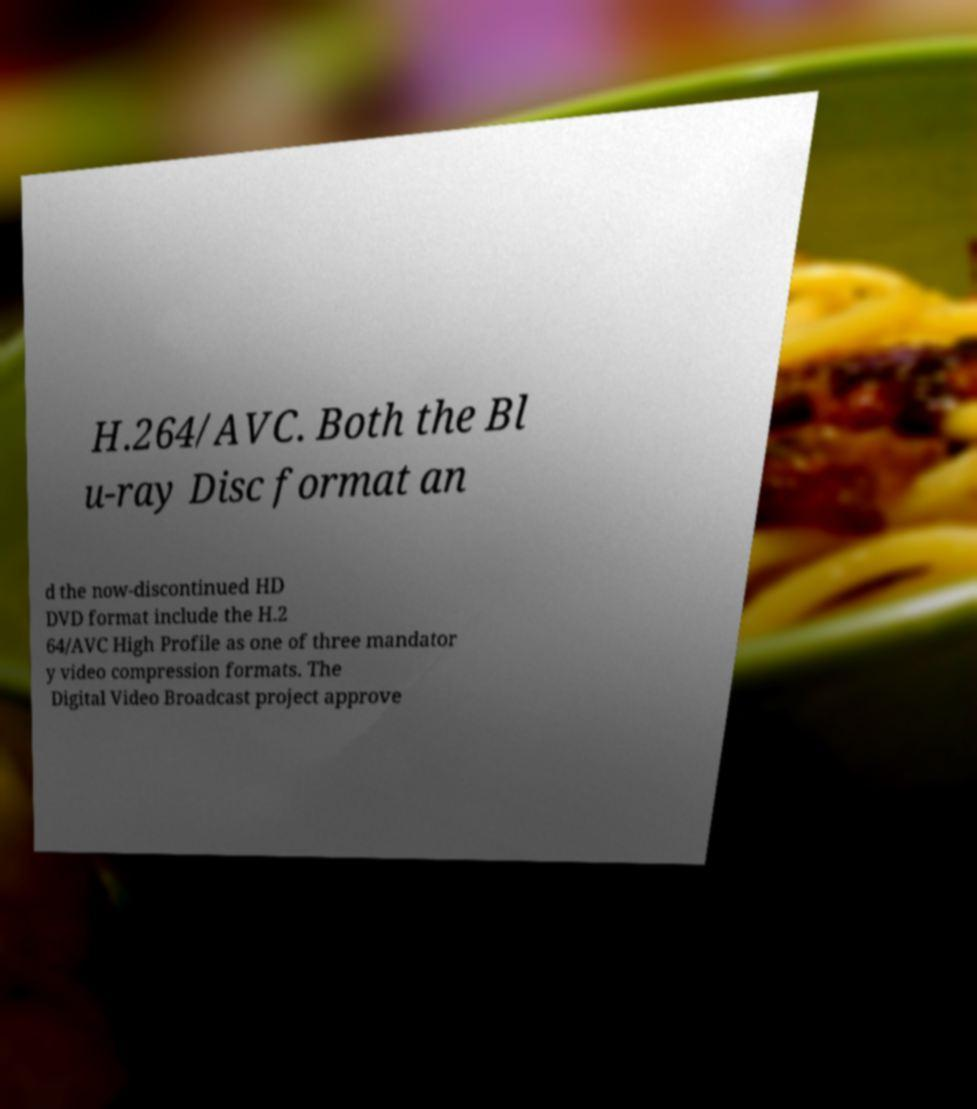Can you accurately transcribe the text from the provided image for me? H.264/AVC. Both the Bl u-ray Disc format an d the now-discontinued HD DVD format include the H.2 64/AVC High Profile as one of three mandator y video compression formats. The Digital Video Broadcast project approve 